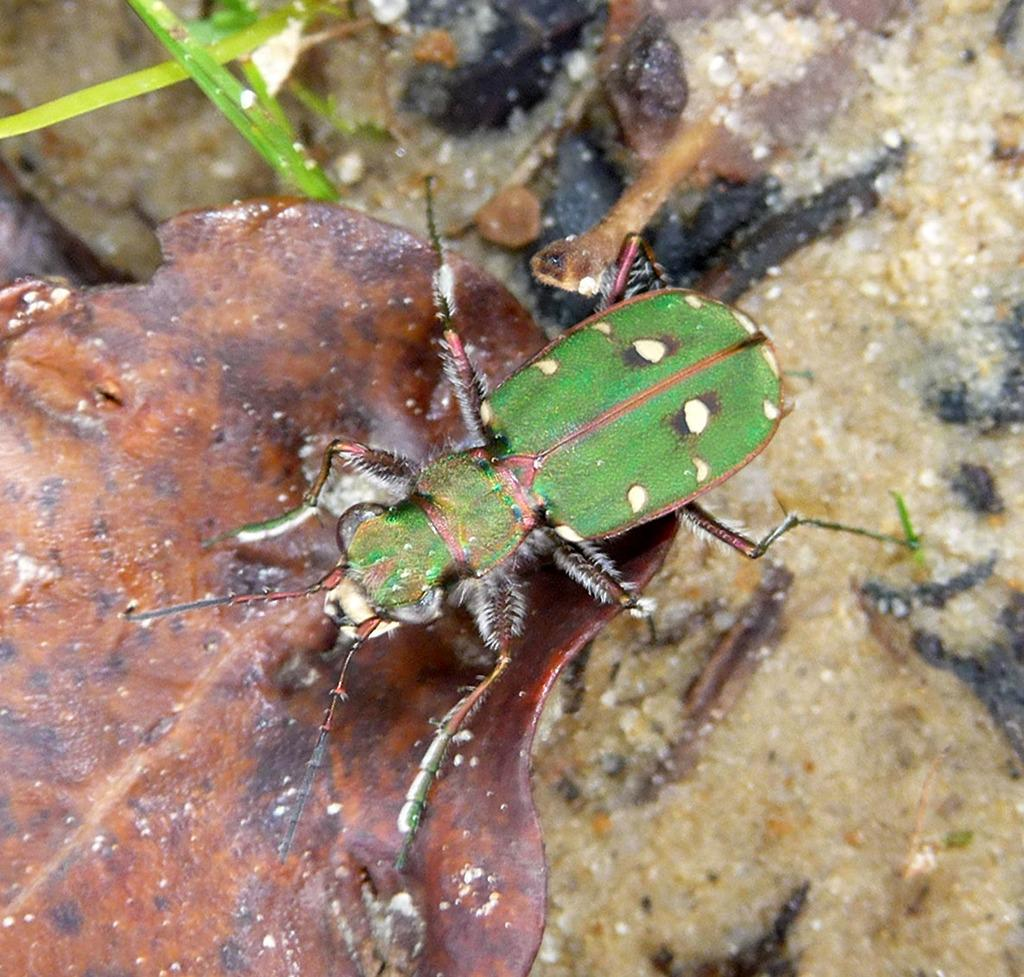What type of creature is present in the image? There is an insect in the image. Where is the insect located? The insect is on a leaf. What letter is the tiger writing on the leaf in the image? There is no tiger present in the image, and therefore no such activity can be observed. 